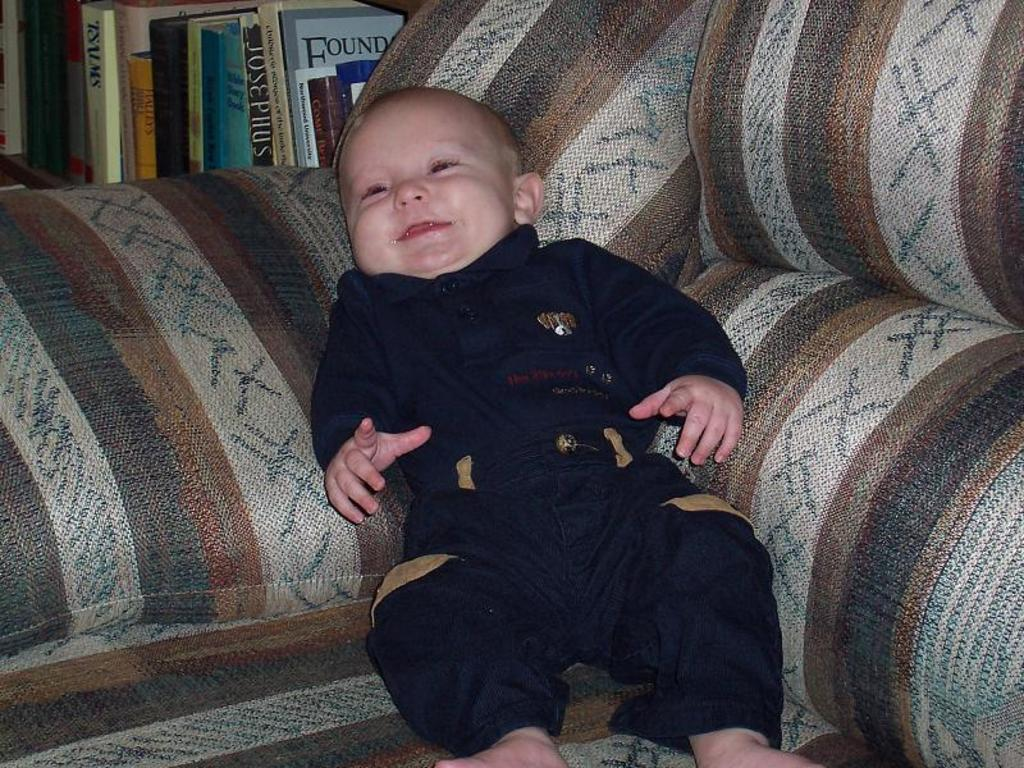Where was the image taken? The image was taken indoors. What can be seen in the background of the image? There are many books in the background of the image. What is the main subject of the image? A baby is lying on a couch in the middle of the image. What type of ship can be seen in the background of the image? There is no ship present in the image; it was taken indoors and features a baby lying on a couch with books in the background. 